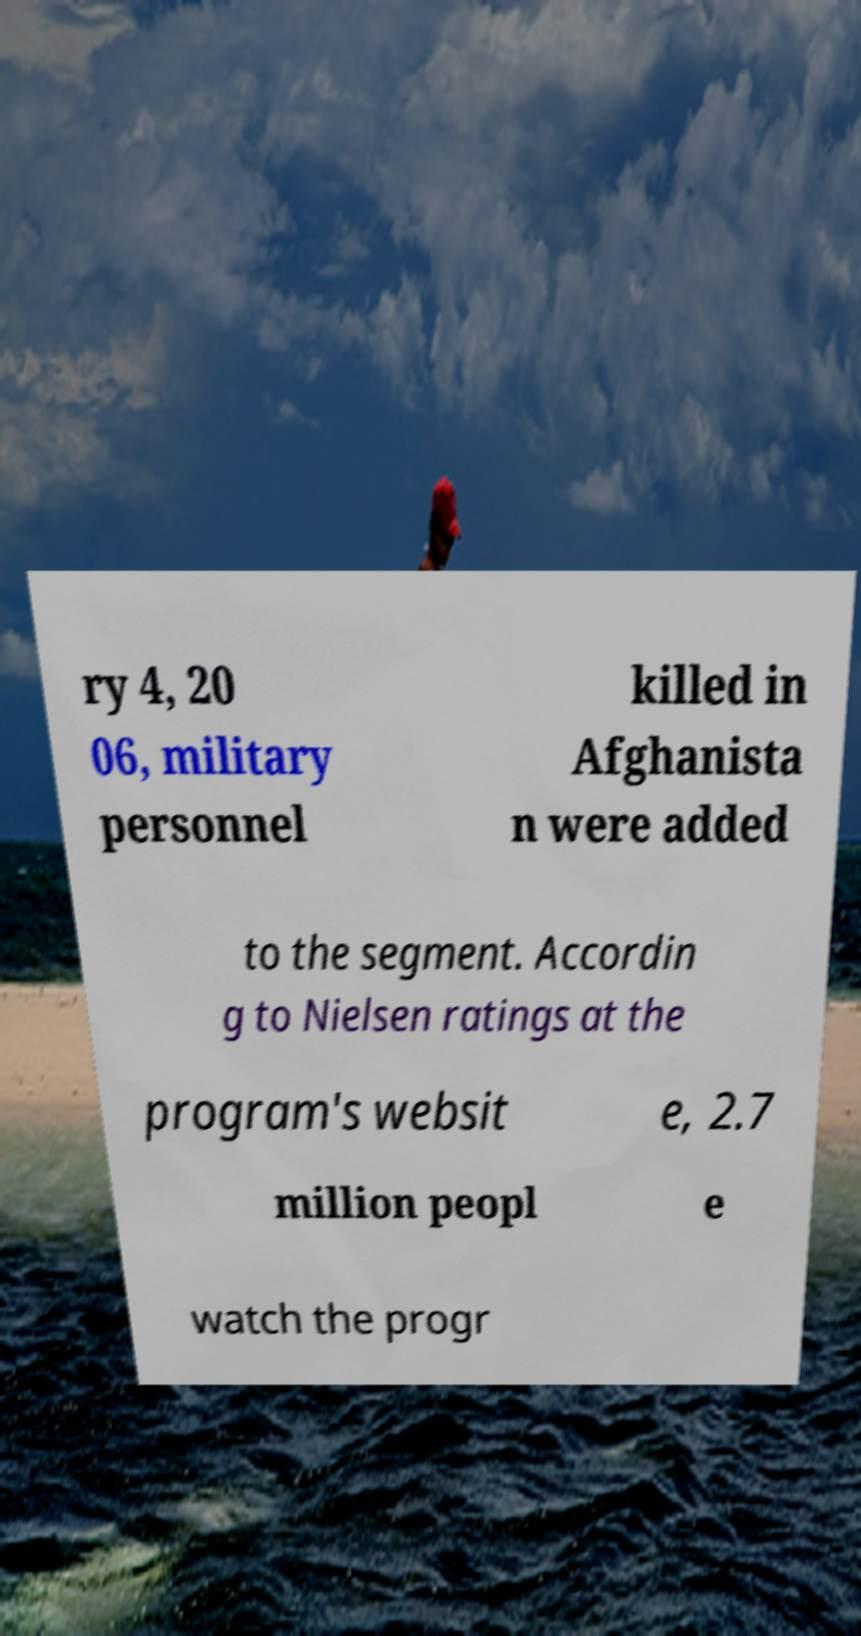I need the written content from this picture converted into text. Can you do that? ry 4, 20 06, military personnel killed in Afghanista n were added to the segment. Accordin g to Nielsen ratings at the program's websit e, 2.7 million peopl e watch the progr 